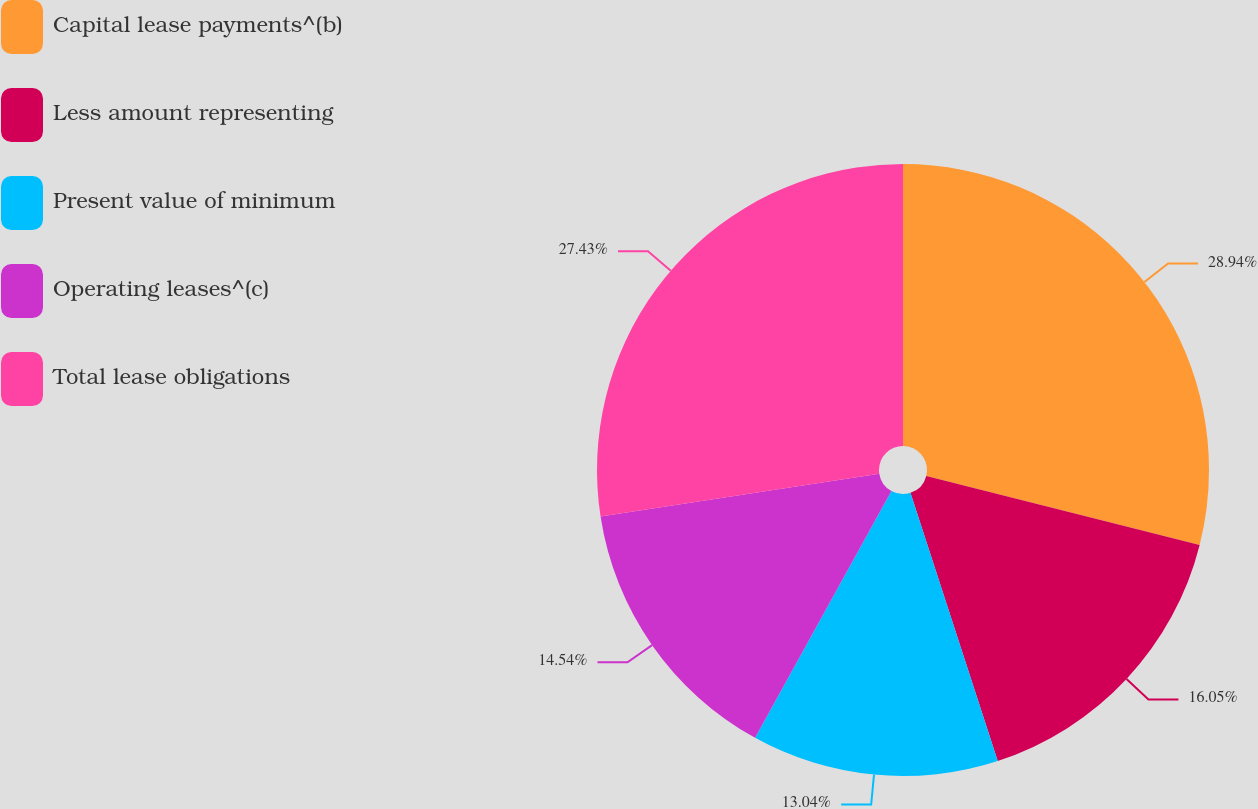<chart> <loc_0><loc_0><loc_500><loc_500><pie_chart><fcel>Capital lease payments^(b)<fcel>Less amount representing<fcel>Present value of minimum<fcel>Operating leases^(c)<fcel>Total lease obligations<nl><fcel>28.94%<fcel>16.05%<fcel>13.04%<fcel>14.54%<fcel>27.43%<nl></chart> 